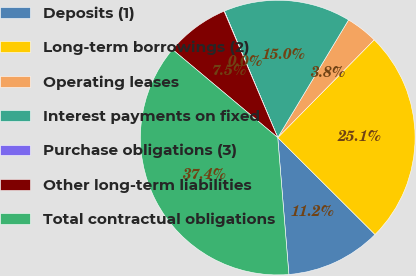<chart> <loc_0><loc_0><loc_500><loc_500><pie_chart><fcel>Deposits (1)<fcel>Long-term borrowings (2)<fcel>Operating leases<fcel>Interest payments on fixed<fcel>Purchase obligations (3)<fcel>Other long-term liabilities<fcel>Total contractual obligations<nl><fcel>11.24%<fcel>25.08%<fcel>3.77%<fcel>14.98%<fcel>0.04%<fcel>7.51%<fcel>37.39%<nl></chart> 